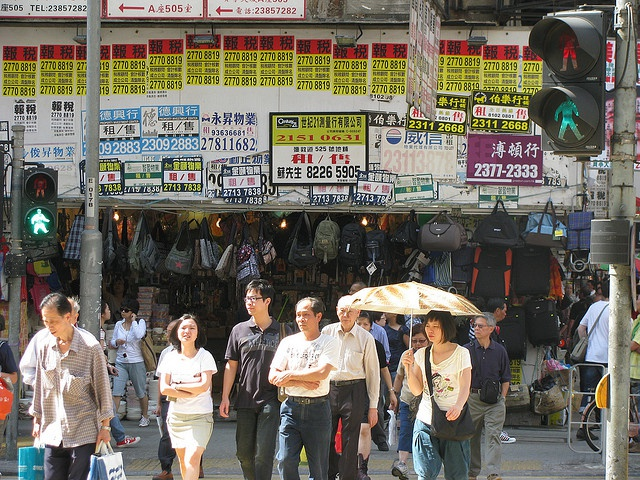Describe the objects in this image and their specific colors. I can see people in darkgray, white, gray, and black tones, traffic light in darkgray, black, gray, and teal tones, people in darkgray, white, black, gray, and tan tones, people in darkgray, black, ivory, tan, and purple tones, and people in darkgray, black, gray, and tan tones in this image. 